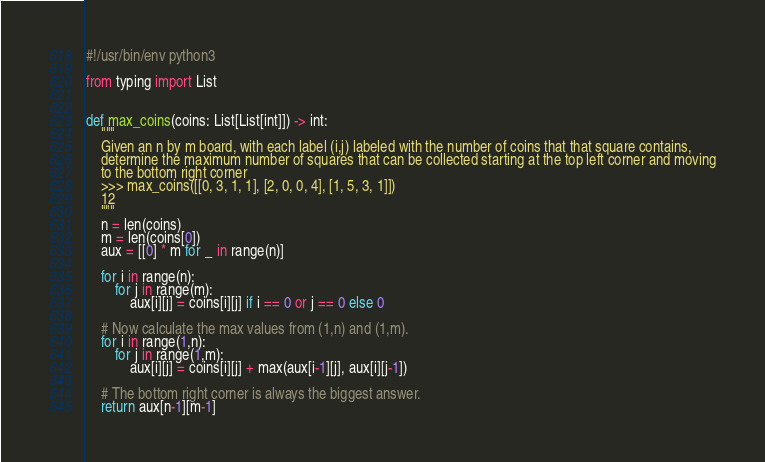Convert code to text. <code><loc_0><loc_0><loc_500><loc_500><_Python_>#!/usr/bin/env python3

from typing import List


def max_coins(coins: List[List[int]]) -> int:
    """
    Given an n by m board, with each label (i,j) labeled with the number of coins that that square contains,
    determine the maximum number of squares that can be collected starting at the top left corner and moving
    to the bottom right corner
    >>> max_coins([[0, 3, 1, 1], [2, 0, 0, 4], [1, 5, 3, 1]])
    12
    """
    n = len(coins)
    m = len(coins[0])
    aux = [[0] * m for _ in range(n)]

    for i in range(n):
        for j in range(m):
            aux[i][j] = coins[i][j] if i == 0 or j == 0 else 0

    # Now calculate the max values from (1,n) and (1,m).
    for i in range(1,n):
        for j in range(1,m):
            aux[i][j] = coins[i][j] + max(aux[i-1][j], aux[i][j-1])

    # The bottom right corner is always the biggest answer.
    return aux[n-1][m-1]
</code> 